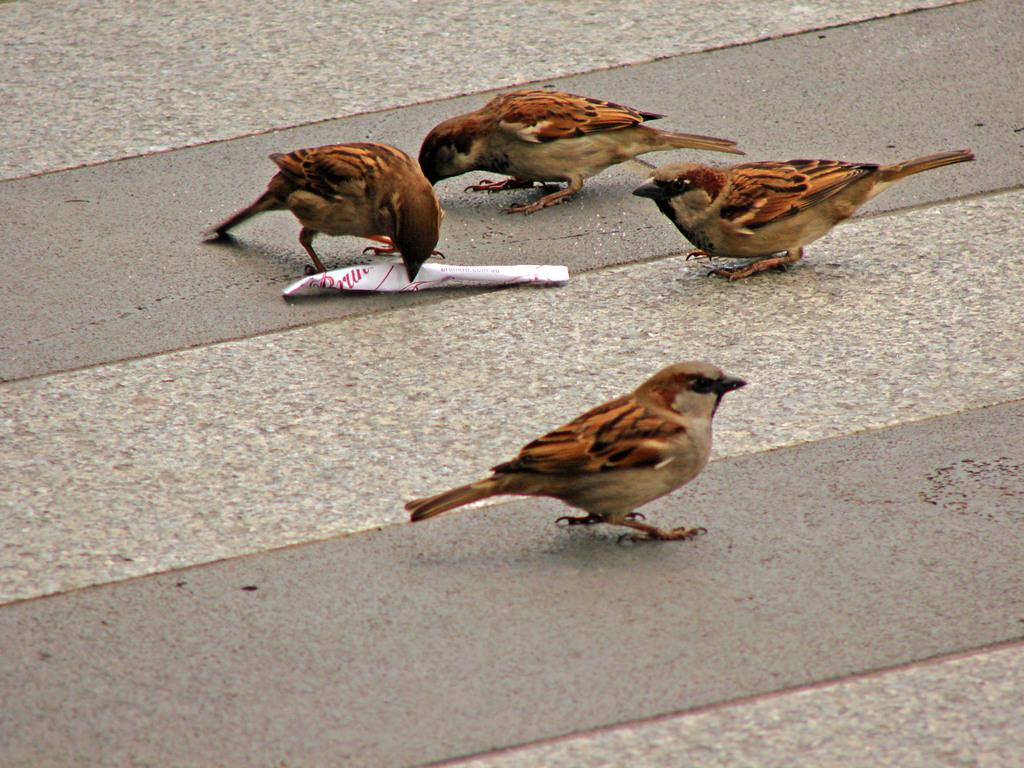How many sparrows are present in the image? There are four sparrows in the image. Where are the sparrows located? The sparrows are on the ground. What else is on the ground in the image? There is a paper on the ground. What is the sparrows' interaction with the paper? One sparrow is holding the paper with its beak. What type of meat can be seen hanging from the tree in the image? There is no tree or meat present in the image; it features four sparrows on the ground with a paper. 